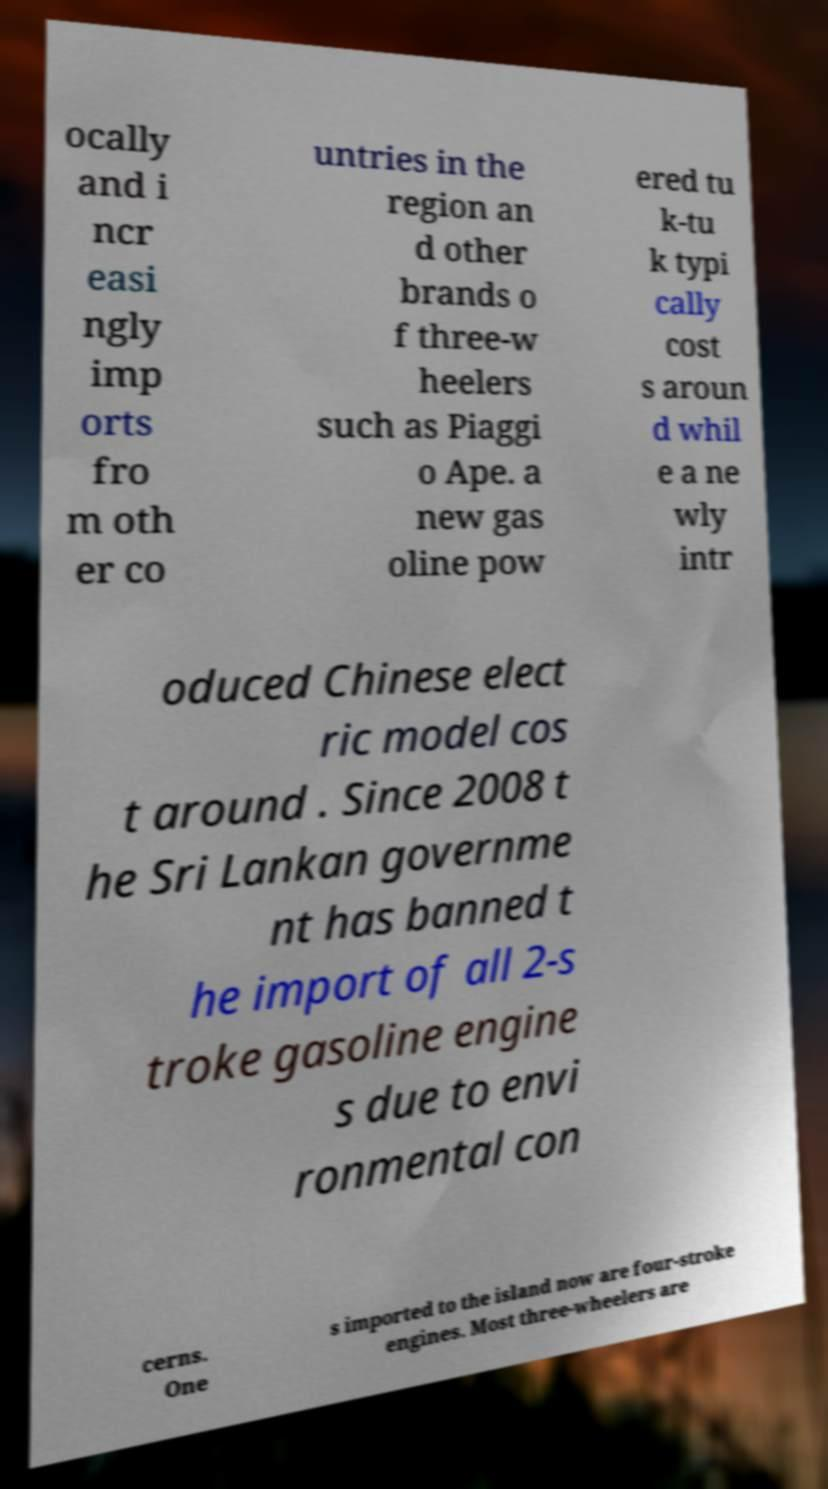Can you accurately transcribe the text from the provided image for me? ocally and i ncr easi ngly imp orts fro m oth er co untries in the region an d other brands o f three-w heelers such as Piaggi o Ape. a new gas oline pow ered tu k-tu k typi cally cost s aroun d whil e a ne wly intr oduced Chinese elect ric model cos t around . Since 2008 t he Sri Lankan governme nt has banned t he import of all 2-s troke gasoline engine s due to envi ronmental con cerns. One s imported to the island now are four-stroke engines. Most three-wheelers are 